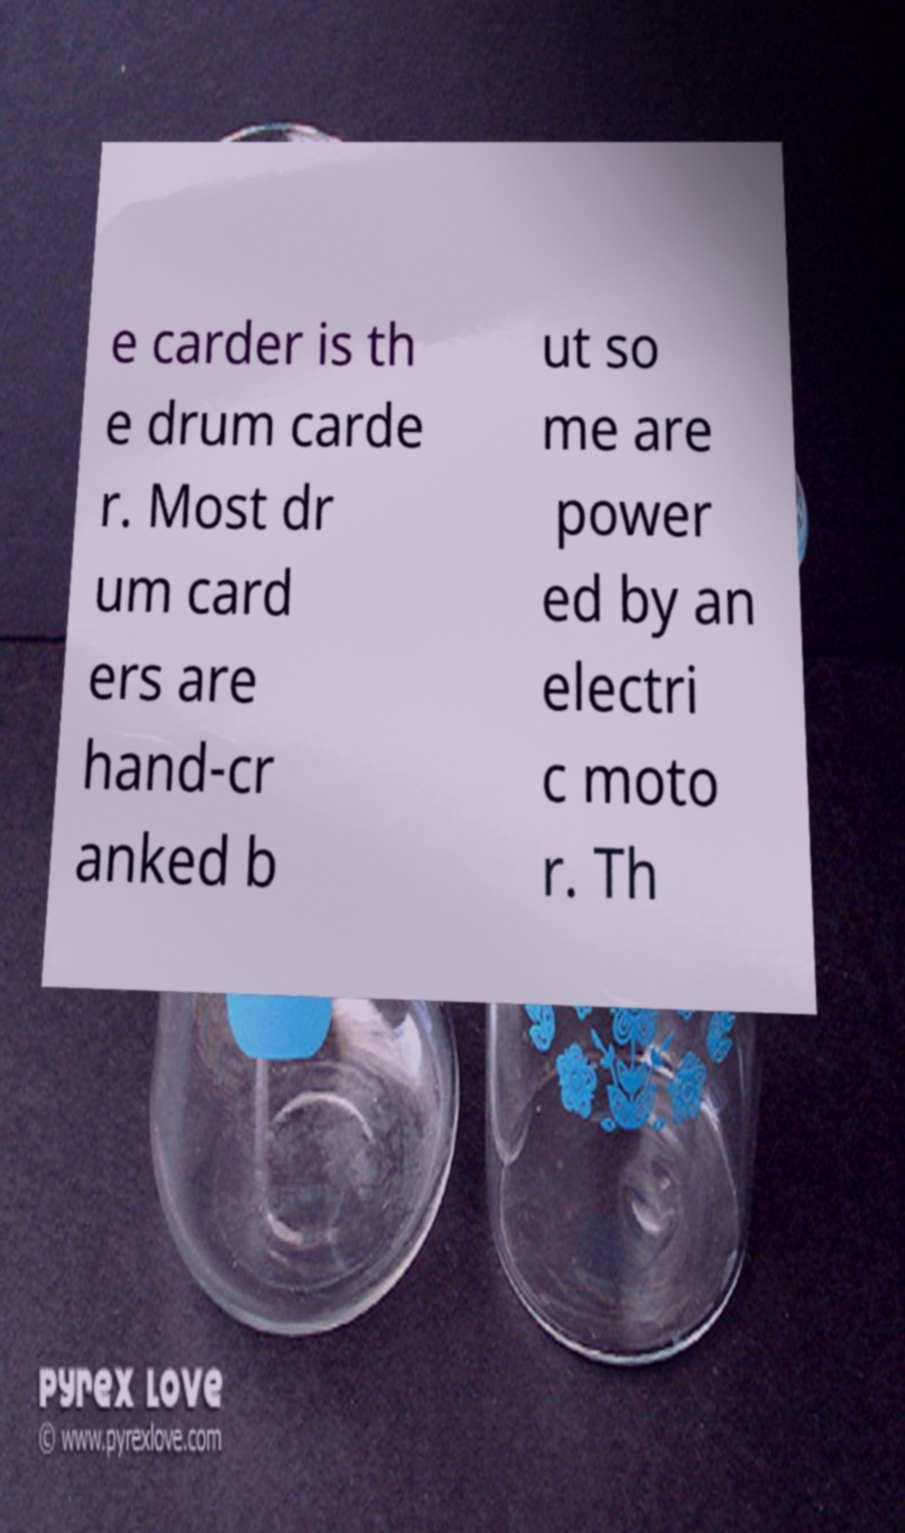What messages or text are displayed in this image? I need them in a readable, typed format. e carder is th e drum carde r. Most dr um card ers are hand-cr anked b ut so me are power ed by an electri c moto r. Th 